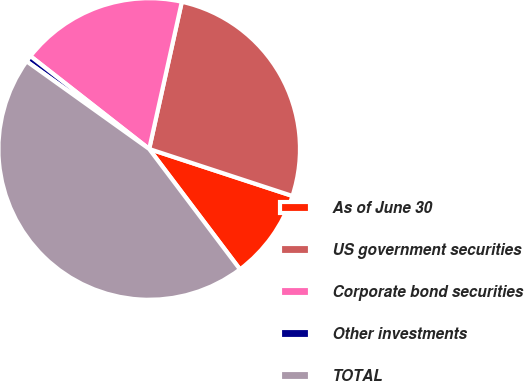<chart> <loc_0><loc_0><loc_500><loc_500><pie_chart><fcel>As of June 30<fcel>US government securities<fcel>Corporate bond securities<fcel>Other investments<fcel>TOTAL<nl><fcel>9.67%<fcel>26.57%<fcel>17.91%<fcel>0.68%<fcel>45.16%<nl></chart> 